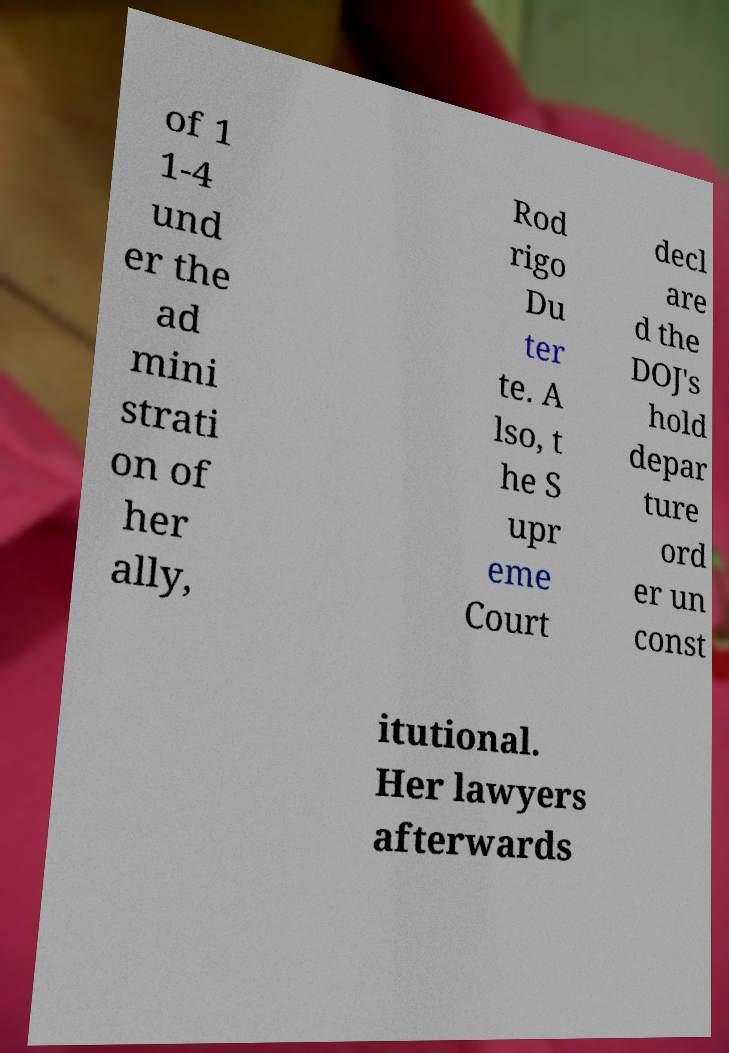Could you assist in decoding the text presented in this image and type it out clearly? of 1 1-4 und er the ad mini strati on of her ally, Rod rigo Du ter te. A lso, t he S upr eme Court decl are d the DOJ's hold depar ture ord er un const itutional. Her lawyers afterwards 